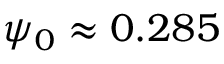<formula> <loc_0><loc_0><loc_500><loc_500>\psi _ { 0 } \approx 0 . 2 8 5</formula> 